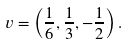Convert formula to latex. <formula><loc_0><loc_0><loc_500><loc_500>v = \left ( \frac { 1 } { 6 } , \frac { 1 } { 3 } , - \frac { 1 } { 2 } \right ) .</formula> 